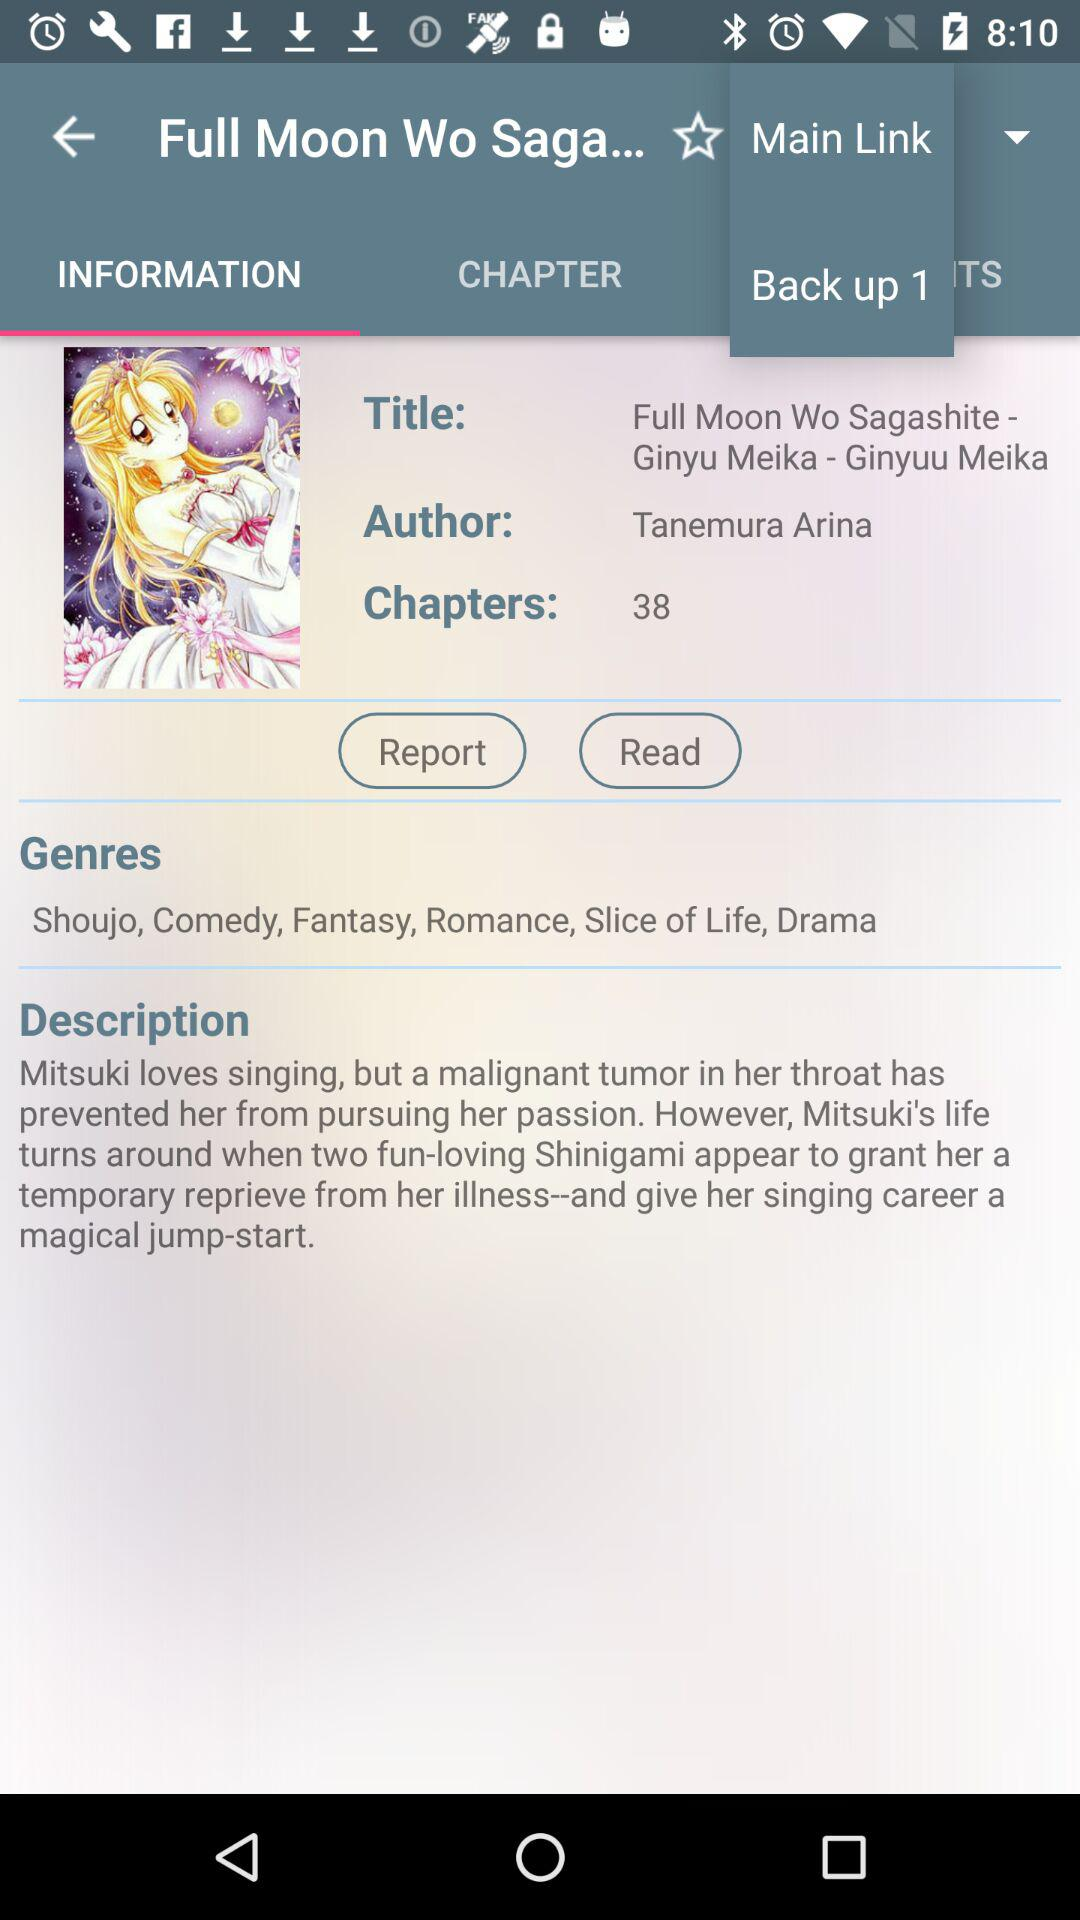What are the genres? The genres are shounen, comedy, fantasy, romance, slice of life and drama. 